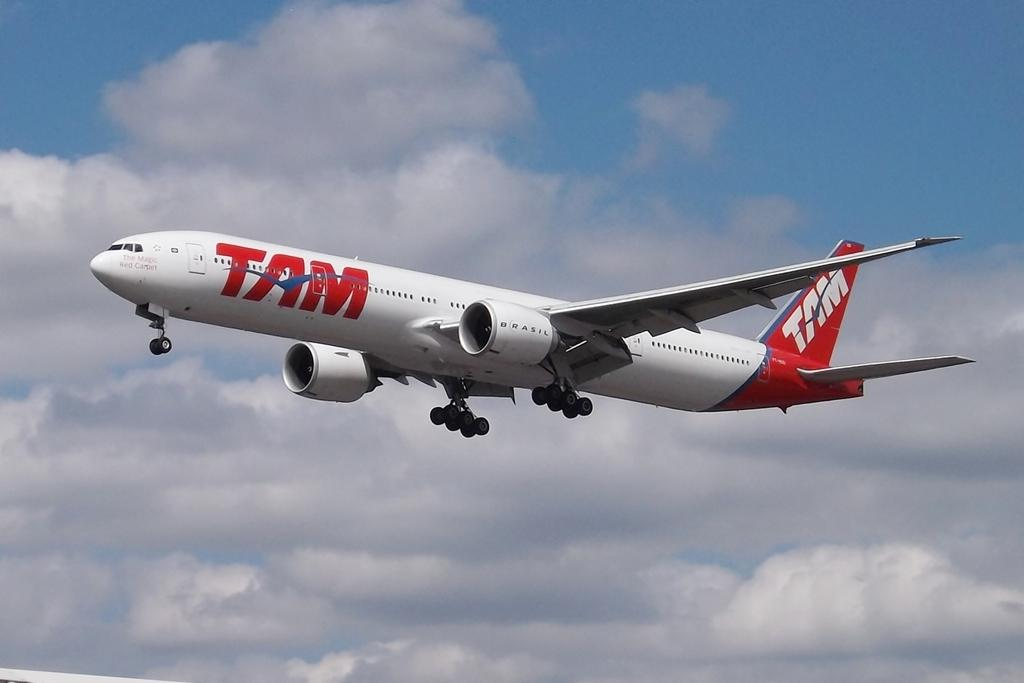<image>
Offer a succinct explanation of the picture presented. A white and red TAM airplane is flying in the air. 